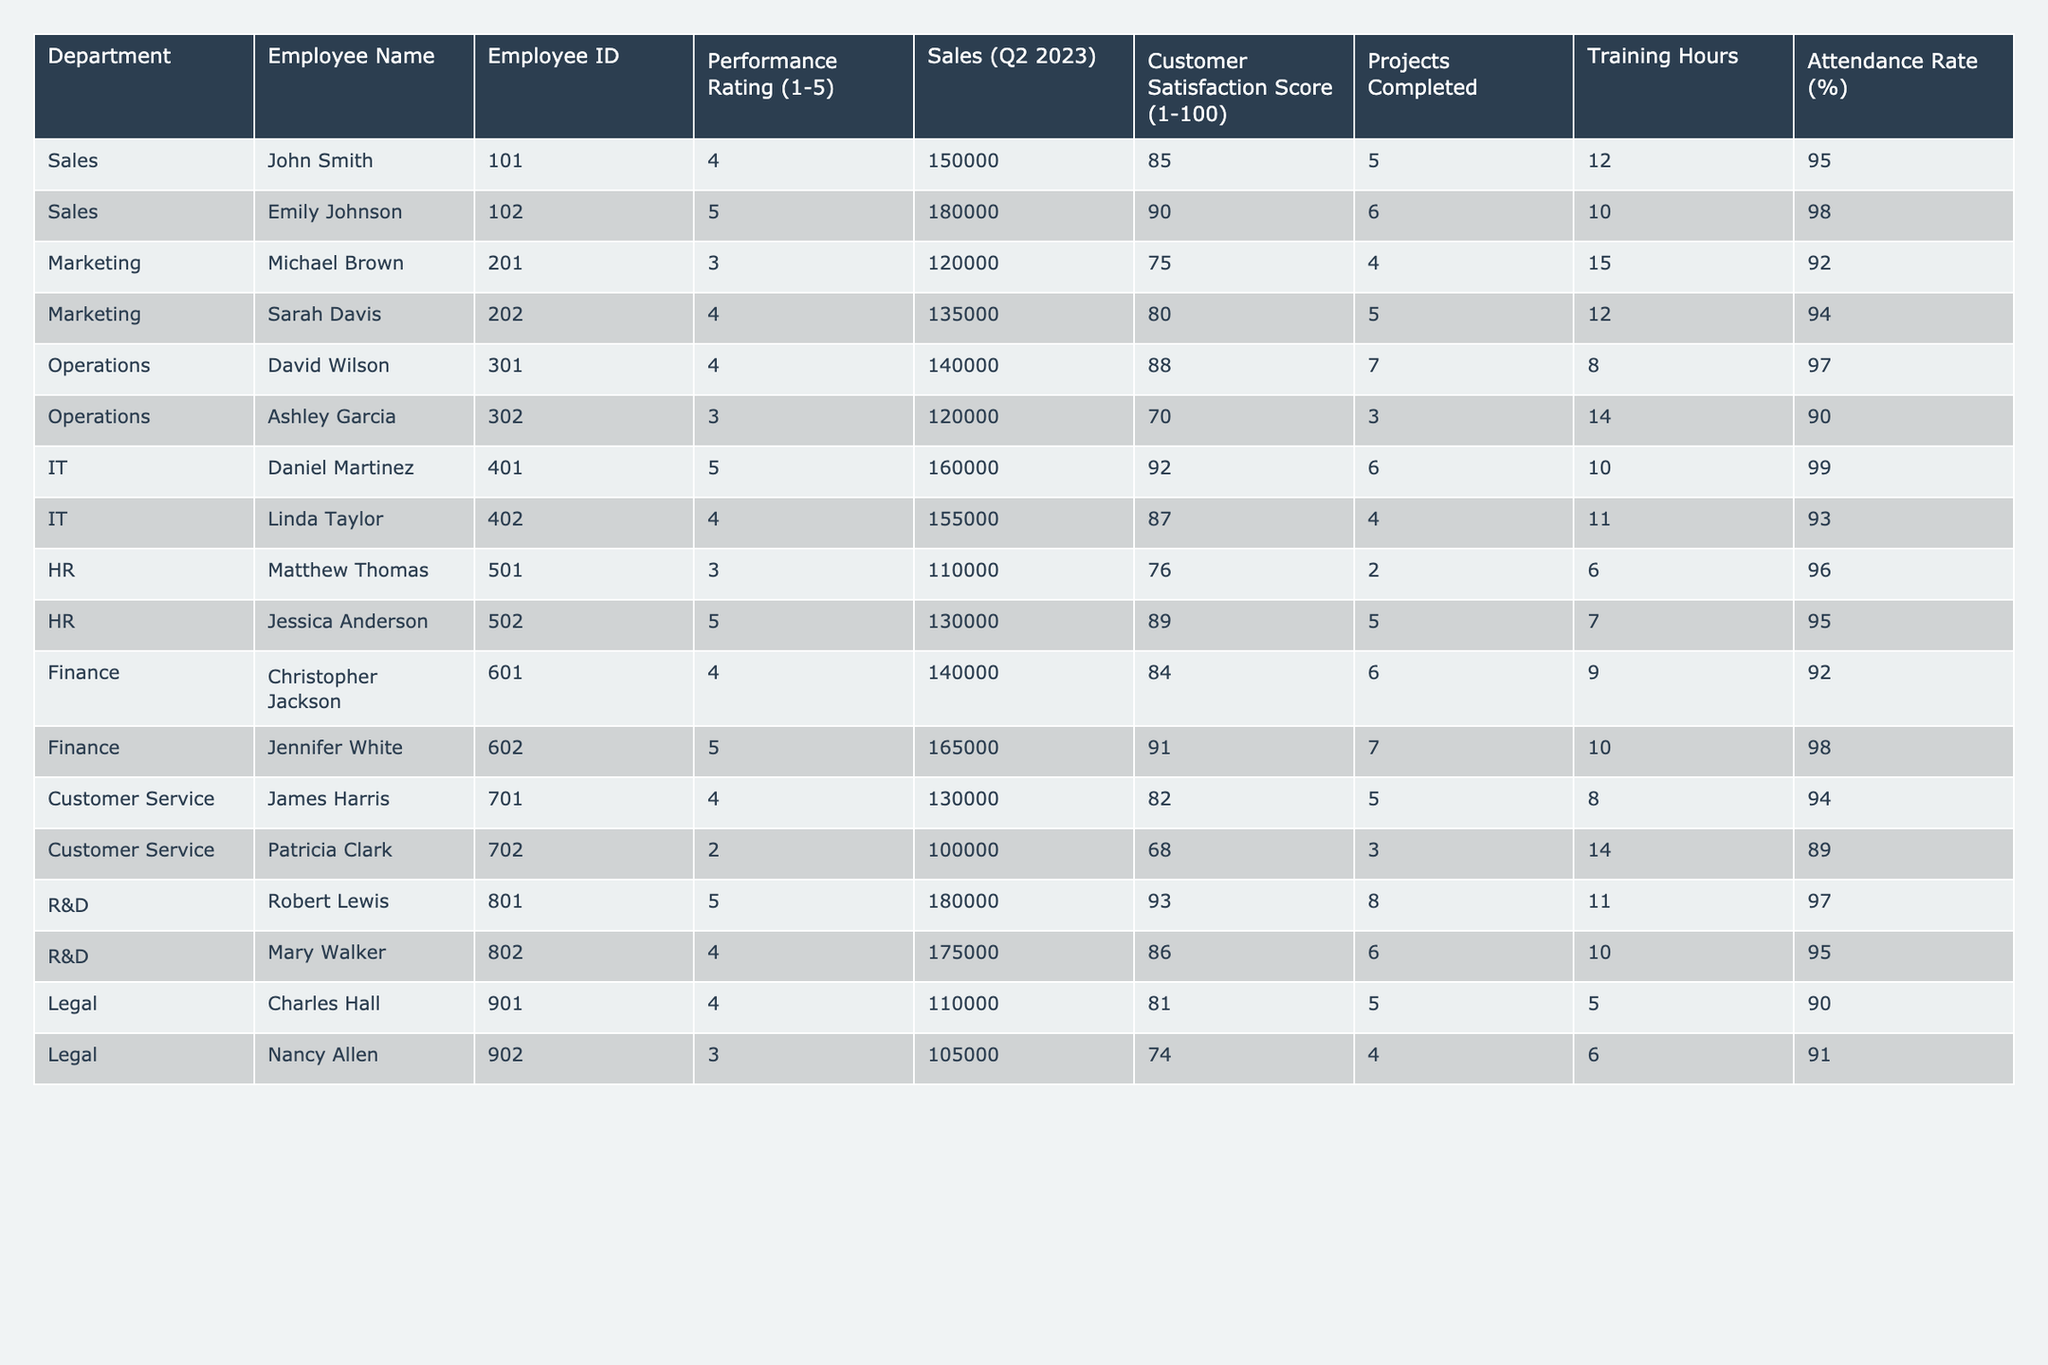What is the highest Performance Rating among the employees? The highest Performance Rating is the maximum value in that column. Upon reviewing, the highest rating in the table is 5.
Answer: 5 Which department has the lowest Customer Satisfaction Score? Looking through the Customer Satisfaction Score column for each department, the lowest score is 68, associated with Patricia Clark in the Customer Service department.
Answer: Customer Service How many projects did Jennifer White complete? Jennifer White's row shows she completed 7 projects, which is the direct entry in the Projects Completed column for her data row.
Answer: 7 What is the average Attendance Rate for employees in the IT department? The Attendance Rates for IT department employees Daniel Martinez and Linda Taylor are 99% and 93% respectively. The average is (99 + 93) / 2 = 96.
Answer: 96 Is there any employee with a Performance Rating of 2? Yes, Patricia Clark has a Performance Rating of 2 as noted in her row.
Answer: Yes Which department completed the most projects in Q2 2023? By looking at the Projects Completed column per department, R&D had Robert Lewis and Mary Walker completing 8 and 6 projects respectively, totaling 14 projects, which is higher than any other department total.
Answer: R&D Calculate the total sales made by employees in the Sales department. The total sales for the Sales department are 150,000 (John Smith) + 180,000 (Emily Johnson) = 330,000.
Answer: 330000 What percentage of employees have a Performance Rating of 4 or higher? The Performance Ratings of 4 or higher are 5 out of 12 entries (John Smith, Emily Johnson, David Wilson, Daniel Martinez, Jessica Anderson, Christopher Jackson, Jennifer White, James Harris, Robert Lewis, and Mary Walker). To find percentage: (5/12) * 100 = 41.67%.
Answer: 41.67% Who has the highest Sales figure in Q2 2023? Reviewing the Sales figures, Emily Johnson has the highest figure at 180,000.
Answer: 180000 How many Training Hours did the employee with the lowest Performance Rating spend on training? The employee with the lowest Performance Rating is Patricia Clark with a rating of 2, and she spent 14 Training Hours as recorded in her row.
Answer: 14 